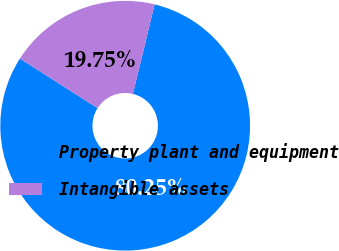Convert chart to OTSL. <chart><loc_0><loc_0><loc_500><loc_500><pie_chart><fcel>Property plant and equipment<fcel>Intangible assets<nl><fcel>80.25%<fcel>19.75%<nl></chart> 